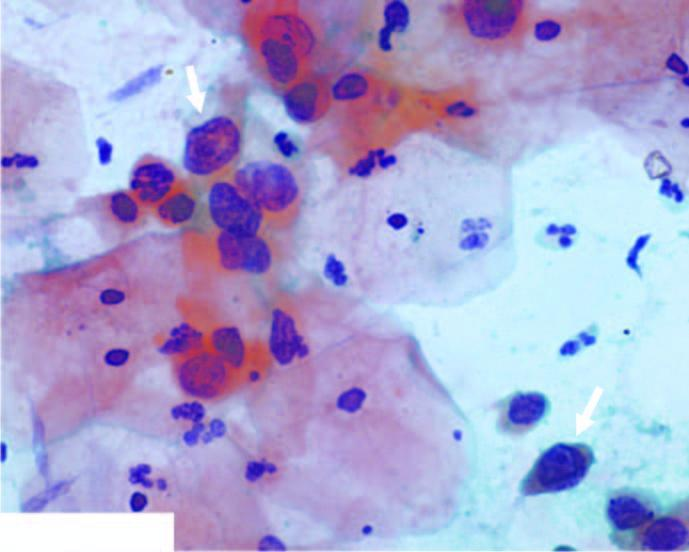what have scanty cytoplasm and markedly hyperchromatic nuclei having irregular nuclear outlines?
Answer the question using a single word or phrase. The squamous cells 